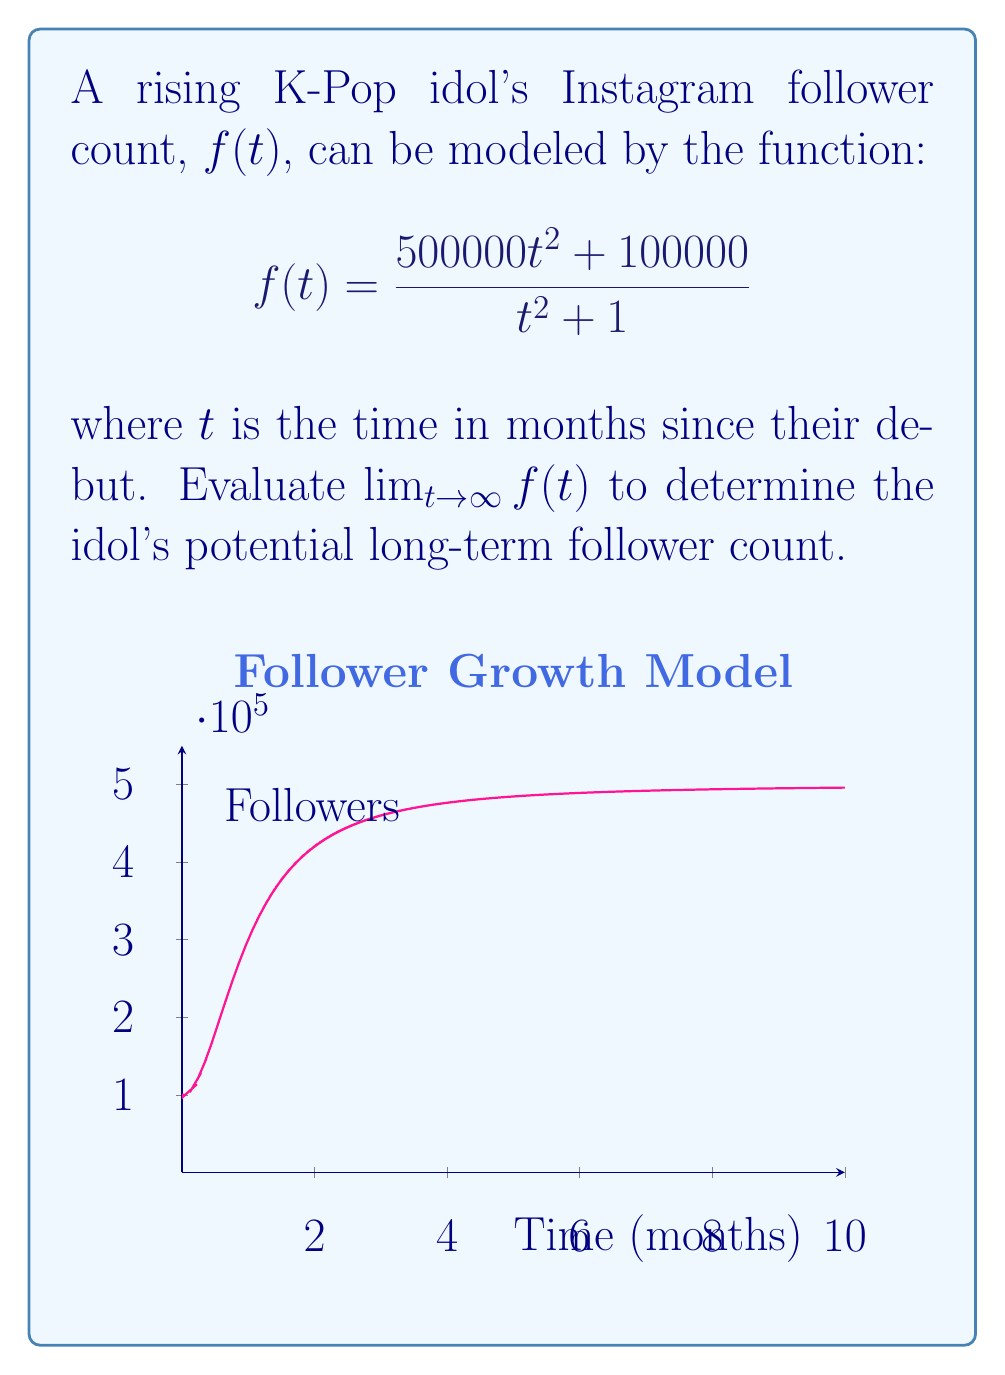Show me your answer to this math problem. Let's approach this step-by-step:

1) To evaluate $\lim_{t \to \infty} f(t)$, we need to look at the behavior of $f(t)$ as $t$ becomes very large.

2) First, let's divide both the numerator and denominator by the highest power of $t$ in the denominator, which is $t^2$:

   $$\lim_{t \to \infty} f(t) = \lim_{t \to \infty} \frac{500000t^2 + 100000}{t^2 + 1}$$
   $$= \lim_{t \to \infty} \frac{500000 + 100000/t^2}{1 + 1/t^2}$$

3) As $t$ approaches infinity, $1/t^2$ approaches 0:

   $$= \frac{500000 + 0}{1 + 0} = 500000$$

4) This means that as time goes on, the follower count approaches 500,000.

5) We can interpret this as the idol's potential long-term follower count if their popularity follows this model.
Answer: $500000$ 